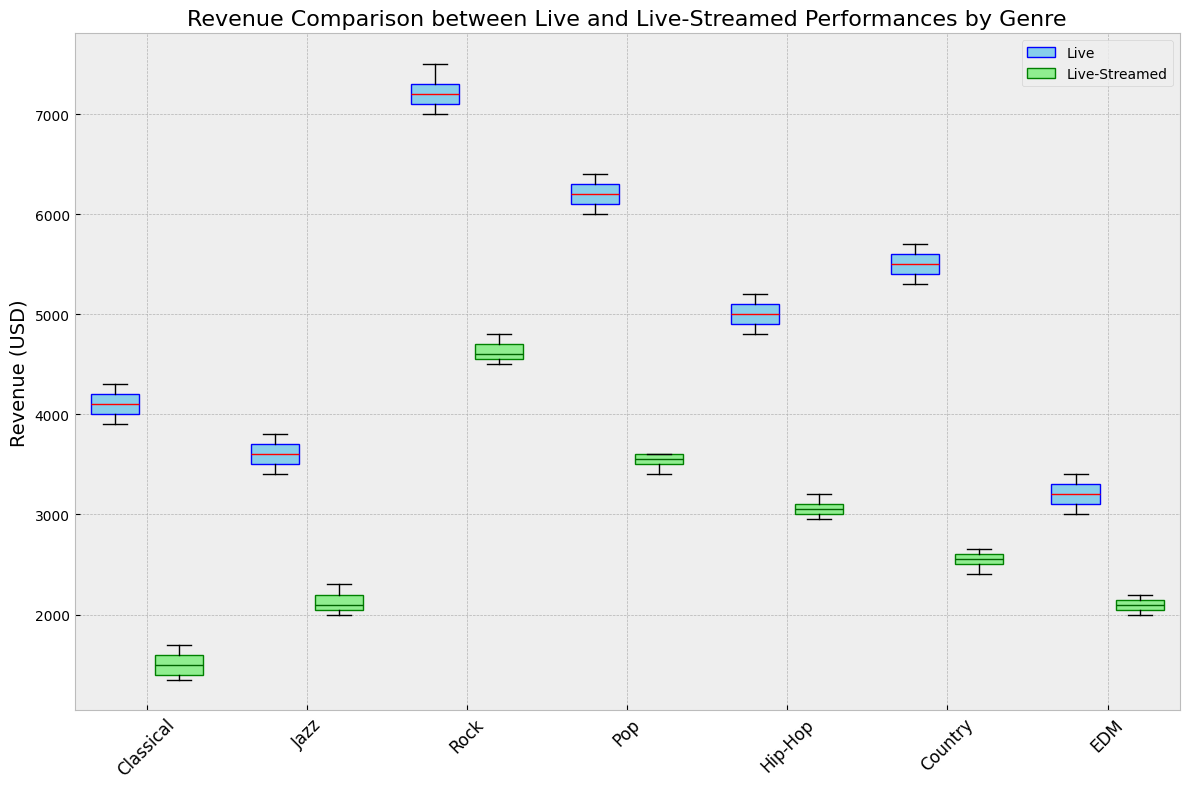What are the median revenues for live and live-streamed performances for Rock musicians? Look at the median lines within the Rock category box plots. The median for live performances is the red line, and for live-streamed performances, it is the dark green line in the respective boxes.
Answer: For live: $7200, For live-streamed: $4600 How does the interquartile range (IQR) of live Jazz performance revenues compare to live-streamed Jazz performance revenues? The IQR is the difference between the first quartile (bottom of the box) and the third quartile (top of the box). Compare the height of the boxes for live and live-streamed Jazz. The live Jazz performances have a slightly wider IQR than the live-streamed Jazz performances.
Answer: Live has a wider IQR Which genre shows the largest drop in revenue when comparing live to live-streamed performances? Identify the differences by comparing the median lines in both boxes for each genre. The largest difference in medians will show the largest drop. Classical has the largest drop in median revenue between live and live-streamed performances.
Answer: Classical What is the lowest revenue recorded for live Hip-Hop performances? Look at the bottom whisker of the Hip-Hop live performance box plot. The lowest point indicates the minimum revenue.
Answer: $4800 Which genre has the narrowest range of revenue for live performances? Compare the height (whiskers) of all the live performance box plots. The genre with the smallest distance between the lowest and highest points (whiskers) has the narrowest range.
Answer: Jazz What are the typical revenue ranges (interquartile ranges) for live and live-streamed Pop performances? The IQR is represented by the height of the box (from the lower to the upper quartile). For live Pop, it ranges from approximately $6100 to $6300. For live-streamed Pop, it ranges from approximately $3500 to $3600.
Answer: Live: $6100 - $6300, Live-streamed: $3500 - $3600 In terms of revenue, which genre's median revenue from live performances is closest to the highest median revenue for live-streamed performances? Identify the highest median revenue for live-streamed performances, which is Rock ($4600). Then, compare all the median revenues for live performances to find the closest one. The closest is the lowest-performing live genre close to the highest live-streamed genre, which is Classical with $4000-$4300 range.
Answer: Classical 